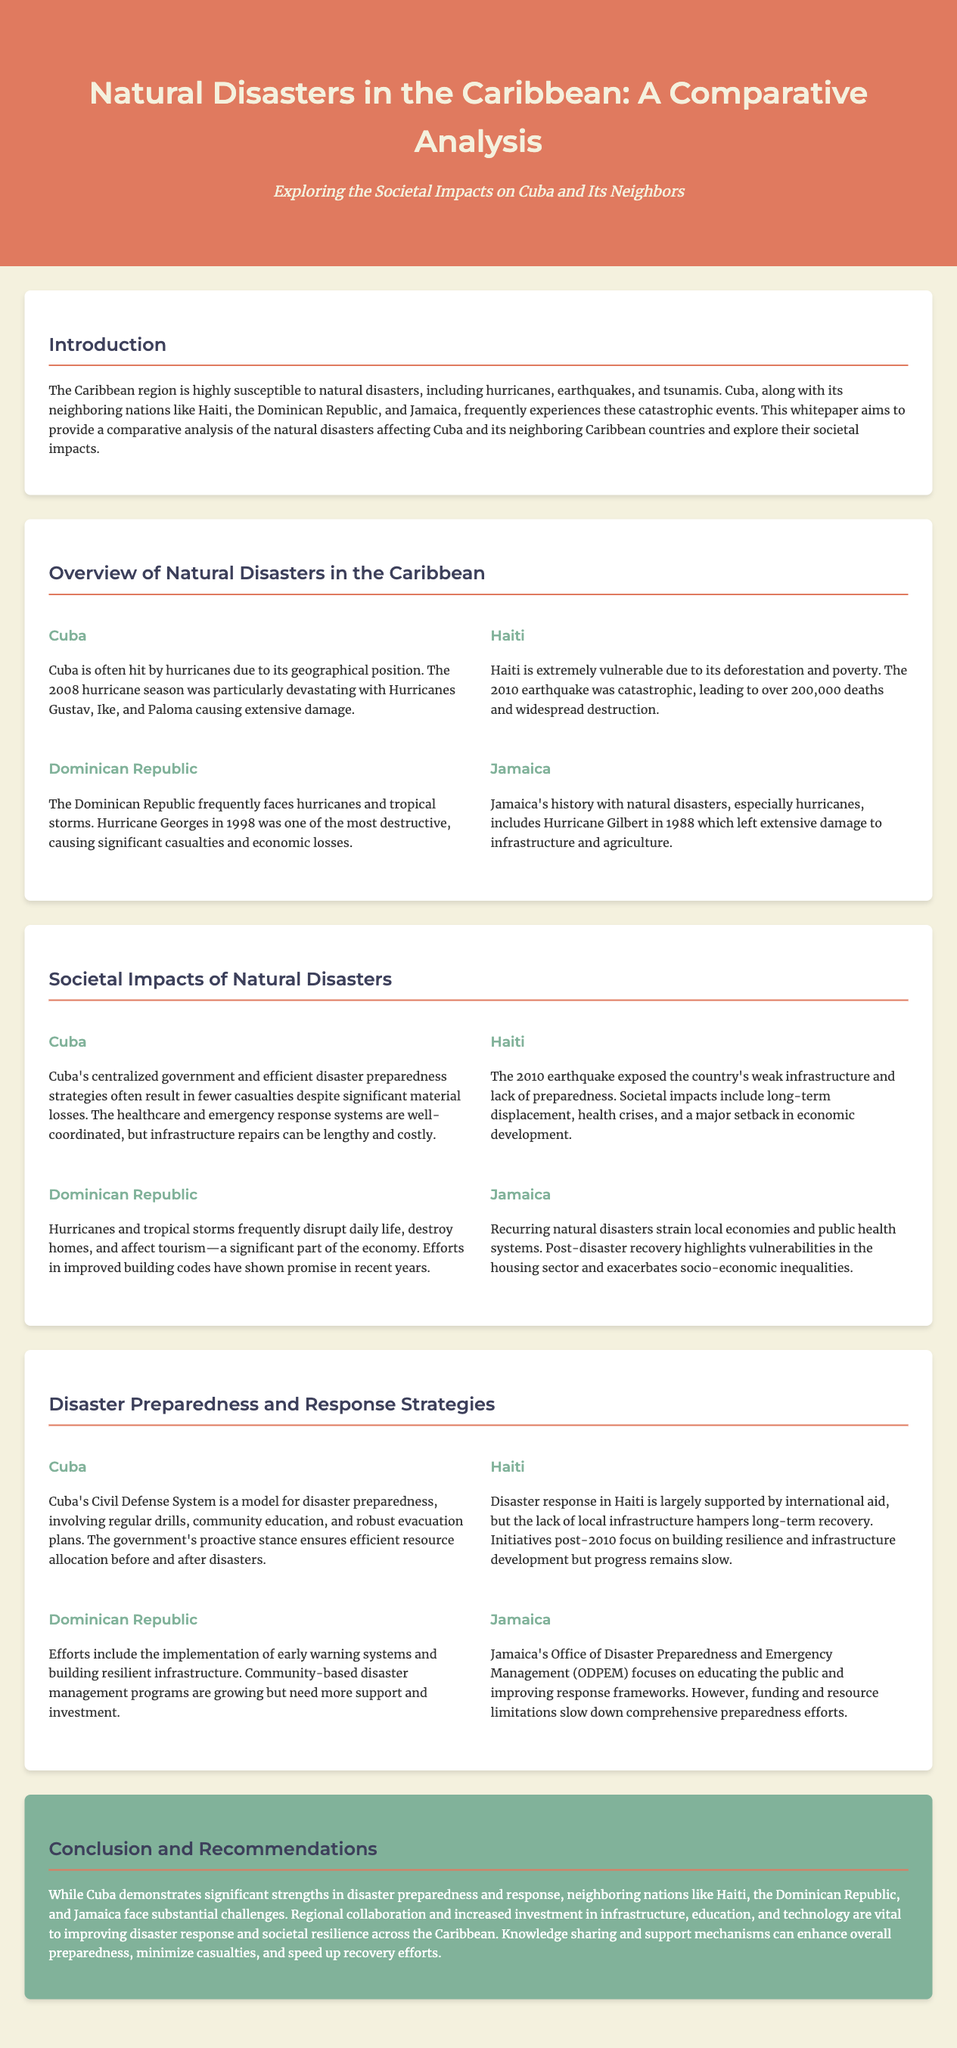what year did the catastrophic earthquake in Haiti occur? The document states that the catastrophic earthquake in Haiti occurred in 2010.
Answer: 2010 which hurricane season was particularly devastating for Cuba? The document mentions that the 2008 hurricane season was particularly devastating for Cuba.
Answer: 2008 what is one of the societal impacts of the 2010 earthquake in Haiti? The document highlights that long-term displacement is one of the societal impacts of the 2010 earthquake in Haiti.
Answer: long-term displacement what disaster preparedness system is mentioned as a model in Cuba? The document refers to Cuba's Civil Defense System as a model for disaster preparedness.
Answer: Civil Defense System which Caribbean nation experienced Hurricane Gilbert in 1988? The document specifies that Jamaica experienced Hurricane Gilbert in 1988.
Answer: Jamaica what is a notable challenge faced by Haiti post-disaster? The document states that the lack of local infrastructure hampers long-term recovery in Haiti.
Answer: lack of local infrastructure what disaster management initiative is growing in the Dominican Republic? The document mentions that community-based disaster management programs are growing in the Dominican Republic.
Answer: community-based disaster management programs what is a significant strength of Cuban disaster response mentioned in the document? The document notes that Cuba's centralized government and efficient disaster preparedness strategies lead to fewer casualties.
Answer: fewer casualties 